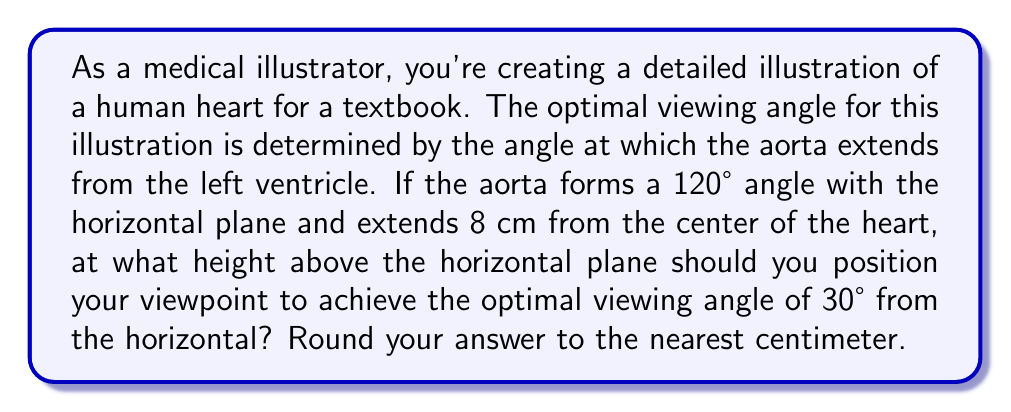Teach me how to tackle this problem. Let's approach this step-by-step using trigonometric functions:

1) First, let's visualize the problem:

[asy]
unitsize(1cm);
pair O=(0,0), A=(8*cos(radians(120)),8*sin(radians(120))), B=(8*cos(radians(120)),0);
draw(O--A--B--O);
draw((0,0)--(10,0),arrow=Arrow(TeXHead));
draw((0,0)--(0,8),arrow=Arrow(TeXHead));
label("O", O, SW);
label("A", A, NE);
label("B", B, SE);
label("8 cm", (O--A)/2, NW);
label("120°", O, NE);
label("x", (0,4), W);
label("30°", (8,0), N);
[/asy]

2) In this diagram, O is the center of the heart, OA represents the aorta, and x is the height we're trying to find.

3) We can use the tangent function to find x. The tangent of an angle is the opposite side divided by the adjacent side.

4) In our case:

   $\tan(30°) = \frac{x}{\text{adjacent}}$

5) We need to find the adjacent side. This is the horizontal distance from O to B.
   We can find this using the cosine function:

   $\cos(120°) = \frac{\text{adjacent}}{8}$

6) Solving for adjacent:

   $\text{adjacent} = 8 \cos(120°) = 8 \cdot (-0.5) = -4$ cm

7) The negative sign indicates it's in the opposite direction, but we're only concerned with the magnitude, so we'll use 4 cm.

8) Now we can set up our tangent equation:

   $\tan(30°) = \frac{x}{4}$

9) Solving for x:

   $x = 4 \tan(30°)$

10) Calculate:

    $x = 4 \cdot 0.577 = 2.308$ cm

11) Rounding to the nearest centimeter:

    $x \approx 2$ cm
Answer: The optimal viewpoint should be positioned approximately 2 cm above the horizontal plane. 